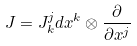<formula> <loc_0><loc_0><loc_500><loc_500>J = J _ { k } ^ { j } d x ^ { k } \otimes \frac { \partial } { \partial x ^ { j } }</formula> 